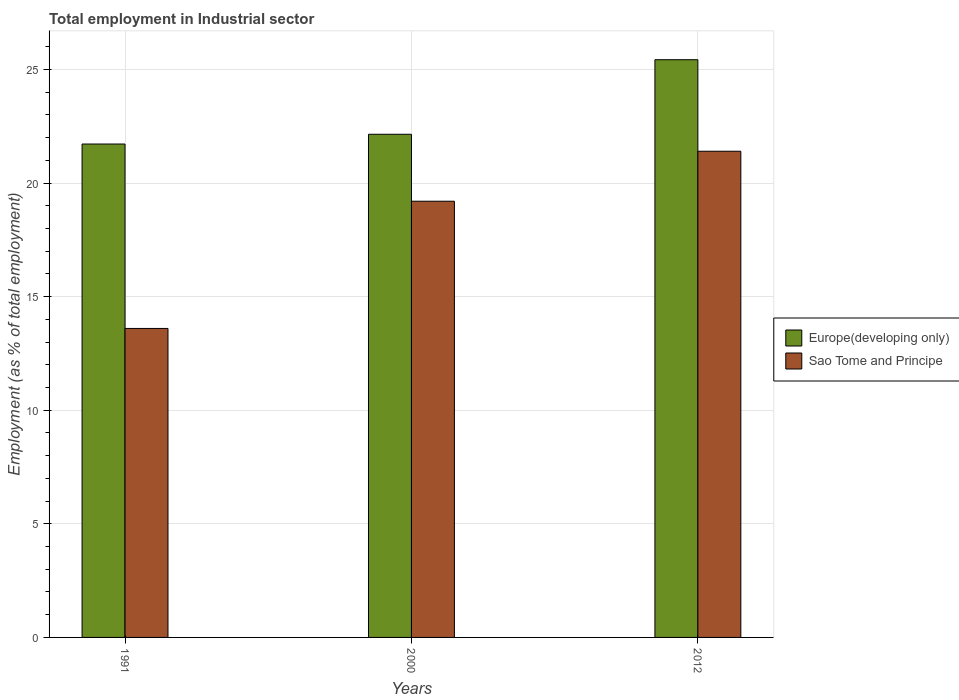How many different coloured bars are there?
Provide a succinct answer. 2. Are the number of bars per tick equal to the number of legend labels?
Offer a very short reply. Yes. Are the number of bars on each tick of the X-axis equal?
Keep it short and to the point. Yes. How many bars are there on the 1st tick from the right?
Offer a very short reply. 2. What is the employment in industrial sector in Europe(developing only) in 1991?
Offer a very short reply. 21.72. Across all years, what is the maximum employment in industrial sector in Sao Tome and Principe?
Your answer should be compact. 21.4. Across all years, what is the minimum employment in industrial sector in Europe(developing only)?
Offer a very short reply. 21.72. What is the total employment in industrial sector in Sao Tome and Principe in the graph?
Your response must be concise. 54.2. What is the difference between the employment in industrial sector in Sao Tome and Principe in 2000 and that in 2012?
Offer a terse response. -2.2. What is the difference between the employment in industrial sector in Sao Tome and Principe in 2012 and the employment in industrial sector in Europe(developing only) in 1991?
Provide a short and direct response. -0.32. What is the average employment in industrial sector in Sao Tome and Principe per year?
Your answer should be compact. 18.07. In the year 1991, what is the difference between the employment in industrial sector in Europe(developing only) and employment in industrial sector in Sao Tome and Principe?
Your answer should be very brief. 8.12. In how many years, is the employment in industrial sector in Sao Tome and Principe greater than 2 %?
Your answer should be compact. 3. What is the ratio of the employment in industrial sector in Sao Tome and Principe in 1991 to that in 2000?
Your response must be concise. 0.71. What is the difference between the highest and the second highest employment in industrial sector in Europe(developing only)?
Offer a terse response. 3.28. What is the difference between the highest and the lowest employment in industrial sector in Europe(developing only)?
Offer a very short reply. 3.71. In how many years, is the employment in industrial sector in Europe(developing only) greater than the average employment in industrial sector in Europe(developing only) taken over all years?
Provide a short and direct response. 1. Is the sum of the employment in industrial sector in Europe(developing only) in 2000 and 2012 greater than the maximum employment in industrial sector in Sao Tome and Principe across all years?
Ensure brevity in your answer.  Yes. What does the 1st bar from the left in 1991 represents?
Offer a very short reply. Europe(developing only). What does the 1st bar from the right in 2012 represents?
Offer a very short reply. Sao Tome and Principe. How many bars are there?
Give a very brief answer. 6. How many years are there in the graph?
Your response must be concise. 3. What is the difference between two consecutive major ticks on the Y-axis?
Provide a succinct answer. 5. Are the values on the major ticks of Y-axis written in scientific E-notation?
Give a very brief answer. No. Does the graph contain any zero values?
Provide a succinct answer. No. Does the graph contain grids?
Ensure brevity in your answer.  Yes. Where does the legend appear in the graph?
Provide a short and direct response. Center right. What is the title of the graph?
Offer a terse response. Total employment in Industrial sector. Does "Portugal" appear as one of the legend labels in the graph?
Provide a short and direct response. No. What is the label or title of the X-axis?
Provide a short and direct response. Years. What is the label or title of the Y-axis?
Provide a short and direct response. Employment (as % of total employment). What is the Employment (as % of total employment) in Europe(developing only) in 1991?
Your answer should be compact. 21.72. What is the Employment (as % of total employment) of Sao Tome and Principe in 1991?
Offer a very short reply. 13.6. What is the Employment (as % of total employment) in Europe(developing only) in 2000?
Your answer should be compact. 22.15. What is the Employment (as % of total employment) in Sao Tome and Principe in 2000?
Keep it short and to the point. 19.2. What is the Employment (as % of total employment) in Europe(developing only) in 2012?
Make the answer very short. 25.43. What is the Employment (as % of total employment) of Sao Tome and Principe in 2012?
Give a very brief answer. 21.4. Across all years, what is the maximum Employment (as % of total employment) in Europe(developing only)?
Keep it short and to the point. 25.43. Across all years, what is the maximum Employment (as % of total employment) of Sao Tome and Principe?
Make the answer very short. 21.4. Across all years, what is the minimum Employment (as % of total employment) in Europe(developing only)?
Your response must be concise. 21.72. Across all years, what is the minimum Employment (as % of total employment) in Sao Tome and Principe?
Offer a terse response. 13.6. What is the total Employment (as % of total employment) of Europe(developing only) in the graph?
Your answer should be compact. 69.29. What is the total Employment (as % of total employment) in Sao Tome and Principe in the graph?
Provide a succinct answer. 54.2. What is the difference between the Employment (as % of total employment) in Europe(developing only) in 1991 and that in 2000?
Your response must be concise. -0.43. What is the difference between the Employment (as % of total employment) of Sao Tome and Principe in 1991 and that in 2000?
Your answer should be very brief. -5.6. What is the difference between the Employment (as % of total employment) in Europe(developing only) in 1991 and that in 2012?
Your answer should be compact. -3.71. What is the difference between the Employment (as % of total employment) of Sao Tome and Principe in 1991 and that in 2012?
Provide a short and direct response. -7.8. What is the difference between the Employment (as % of total employment) in Europe(developing only) in 2000 and that in 2012?
Keep it short and to the point. -3.28. What is the difference between the Employment (as % of total employment) in Europe(developing only) in 1991 and the Employment (as % of total employment) in Sao Tome and Principe in 2000?
Offer a terse response. 2.52. What is the difference between the Employment (as % of total employment) in Europe(developing only) in 1991 and the Employment (as % of total employment) in Sao Tome and Principe in 2012?
Keep it short and to the point. 0.32. What is the difference between the Employment (as % of total employment) in Europe(developing only) in 2000 and the Employment (as % of total employment) in Sao Tome and Principe in 2012?
Ensure brevity in your answer.  0.75. What is the average Employment (as % of total employment) of Europe(developing only) per year?
Provide a succinct answer. 23.1. What is the average Employment (as % of total employment) in Sao Tome and Principe per year?
Your answer should be very brief. 18.07. In the year 1991, what is the difference between the Employment (as % of total employment) in Europe(developing only) and Employment (as % of total employment) in Sao Tome and Principe?
Make the answer very short. 8.12. In the year 2000, what is the difference between the Employment (as % of total employment) in Europe(developing only) and Employment (as % of total employment) in Sao Tome and Principe?
Your answer should be compact. 2.95. In the year 2012, what is the difference between the Employment (as % of total employment) in Europe(developing only) and Employment (as % of total employment) in Sao Tome and Principe?
Your response must be concise. 4.03. What is the ratio of the Employment (as % of total employment) of Europe(developing only) in 1991 to that in 2000?
Provide a short and direct response. 0.98. What is the ratio of the Employment (as % of total employment) of Sao Tome and Principe in 1991 to that in 2000?
Your answer should be compact. 0.71. What is the ratio of the Employment (as % of total employment) in Europe(developing only) in 1991 to that in 2012?
Provide a succinct answer. 0.85. What is the ratio of the Employment (as % of total employment) of Sao Tome and Principe in 1991 to that in 2012?
Offer a terse response. 0.64. What is the ratio of the Employment (as % of total employment) in Europe(developing only) in 2000 to that in 2012?
Ensure brevity in your answer.  0.87. What is the ratio of the Employment (as % of total employment) in Sao Tome and Principe in 2000 to that in 2012?
Provide a short and direct response. 0.9. What is the difference between the highest and the second highest Employment (as % of total employment) of Europe(developing only)?
Offer a very short reply. 3.28. What is the difference between the highest and the second highest Employment (as % of total employment) in Sao Tome and Principe?
Ensure brevity in your answer.  2.2. What is the difference between the highest and the lowest Employment (as % of total employment) in Europe(developing only)?
Ensure brevity in your answer.  3.71. 